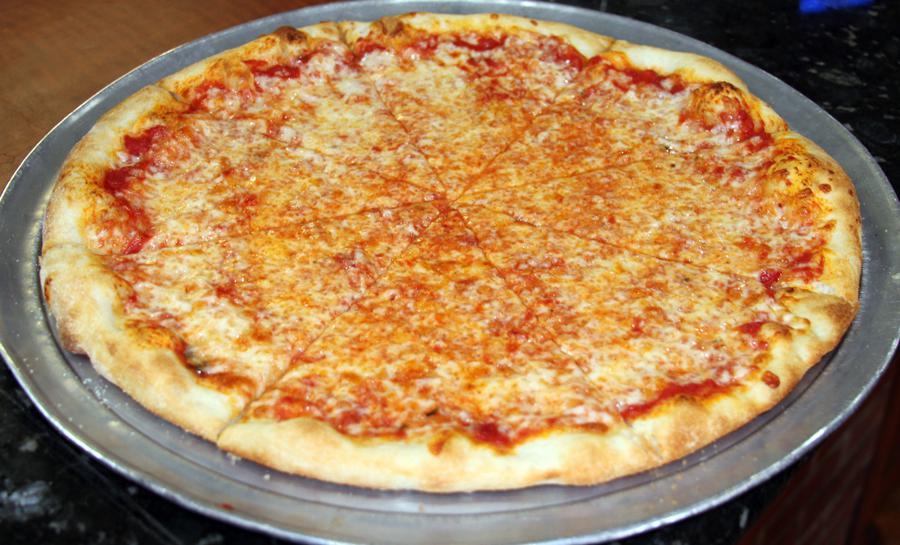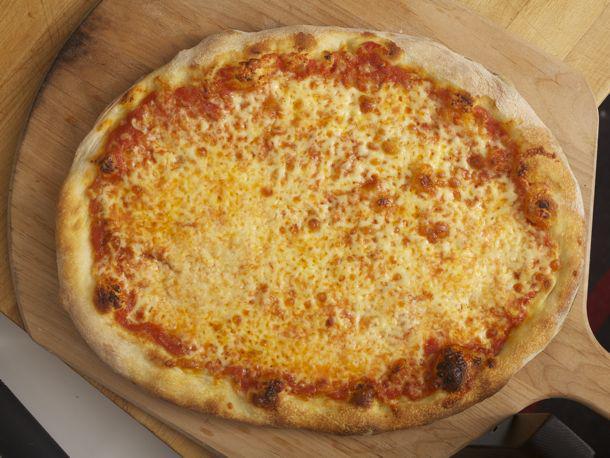The first image is the image on the left, the second image is the image on the right. Evaluate the accuracy of this statement regarding the images: "The pizza in one of the images sits directly on a wooden paddle.". Is it true? Answer yes or no. Yes. The first image is the image on the left, the second image is the image on the right. Assess this claim about the two images: "There are two full circle pizzas.". Correct or not? Answer yes or no. Yes. 